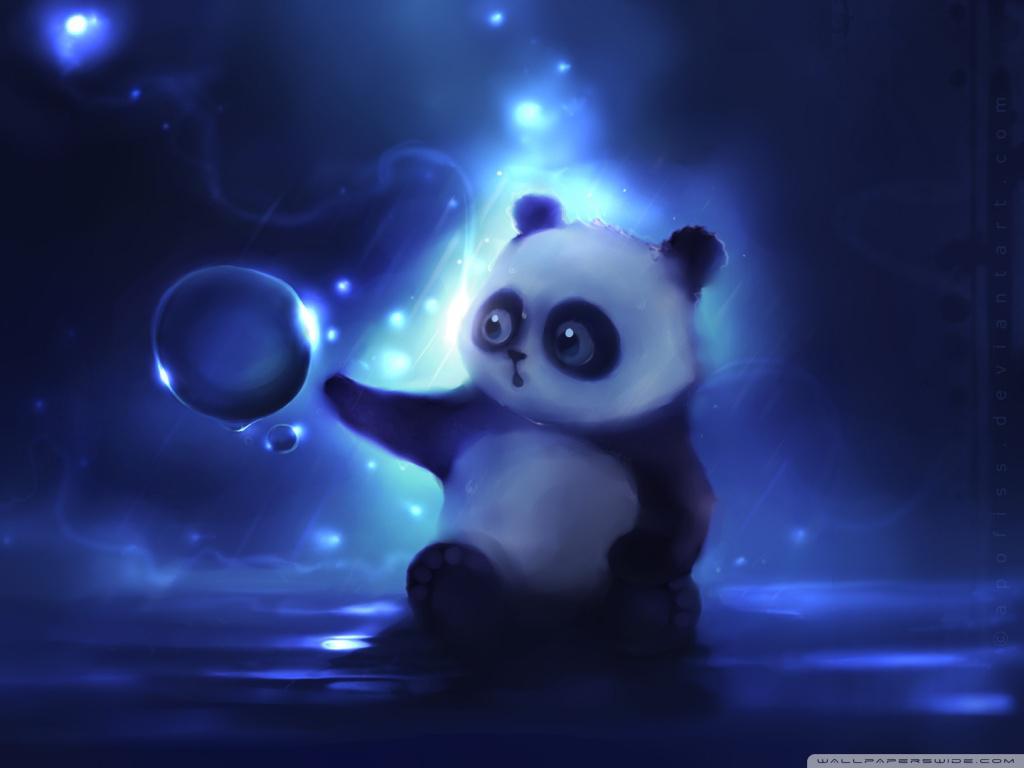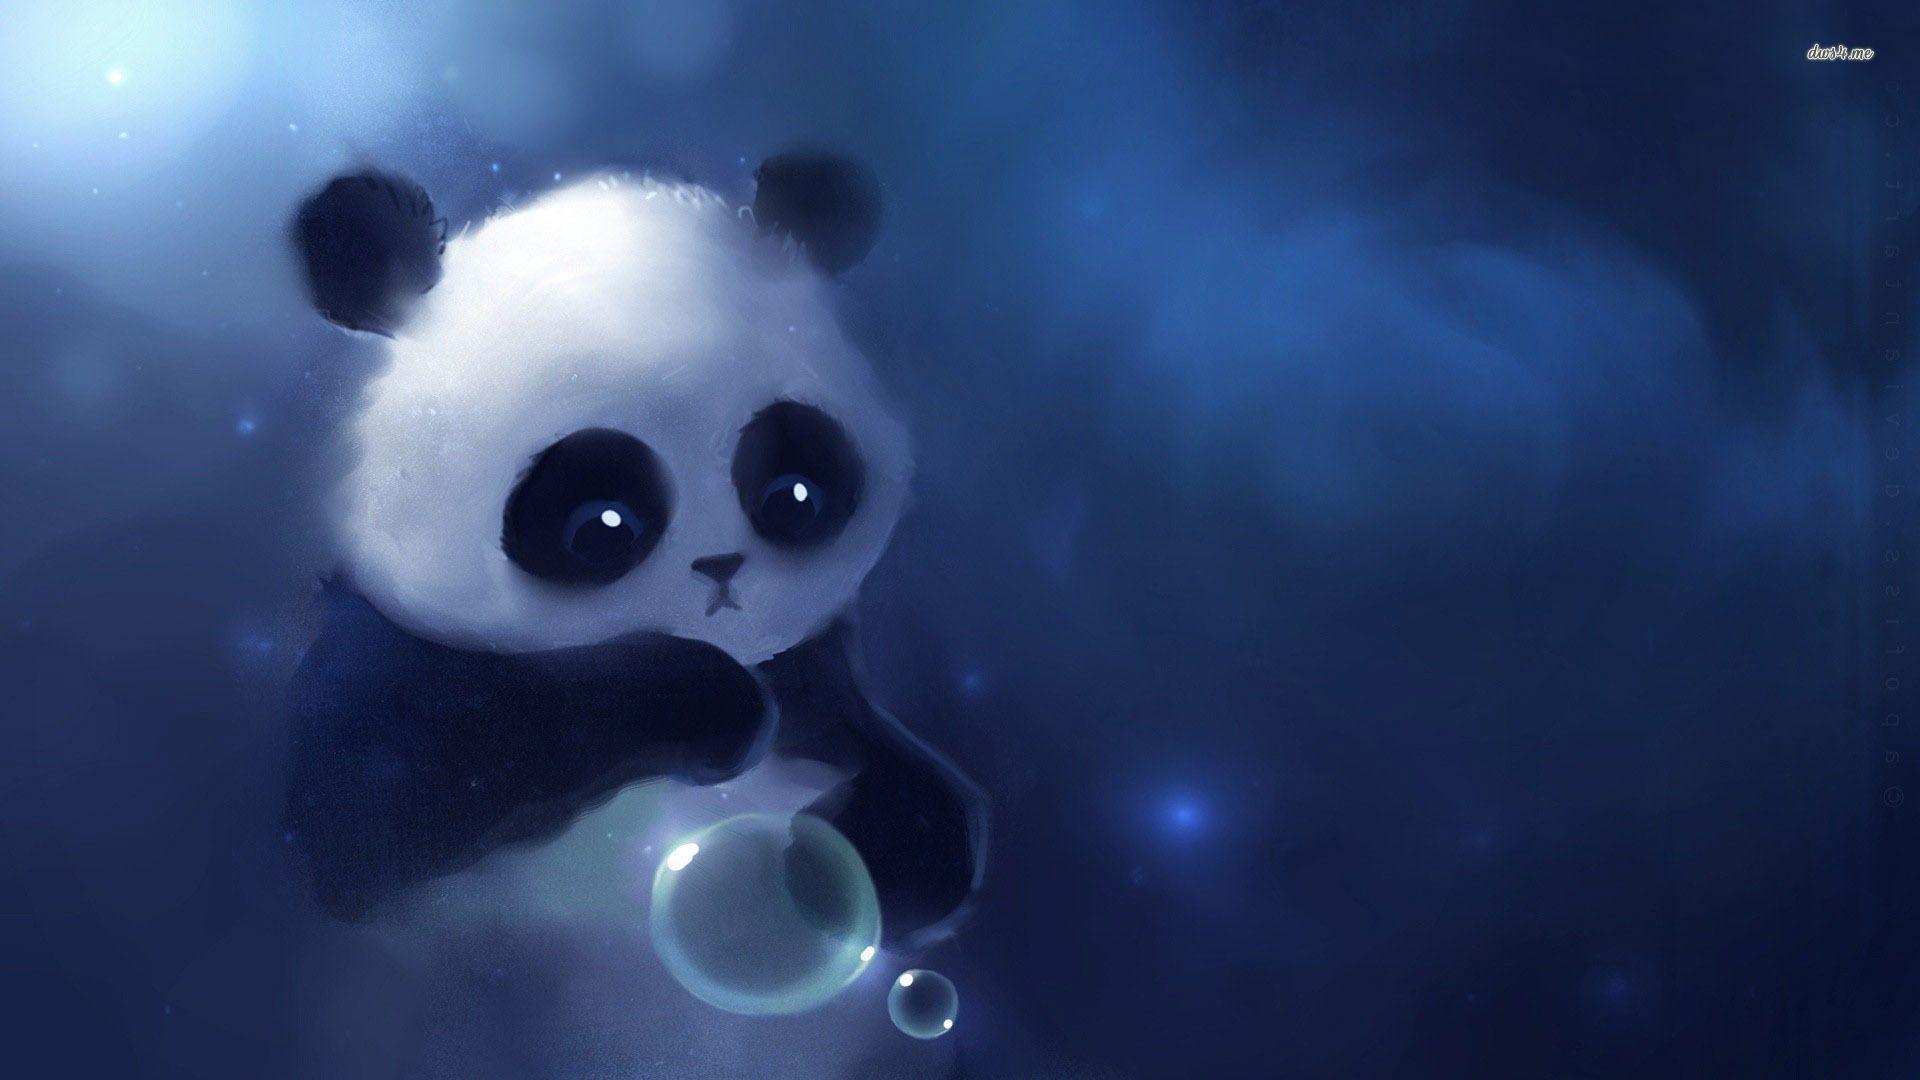The first image is the image on the left, the second image is the image on the right. Considering the images on both sides, is "At least one panda is playing with a bubble." valid? Answer yes or no. Yes. 